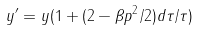<formula> <loc_0><loc_0><loc_500><loc_500>y ^ { \prime } = y ( 1 + ( 2 - \beta p ^ { 2 } / 2 ) d \tau / \tau )</formula> 